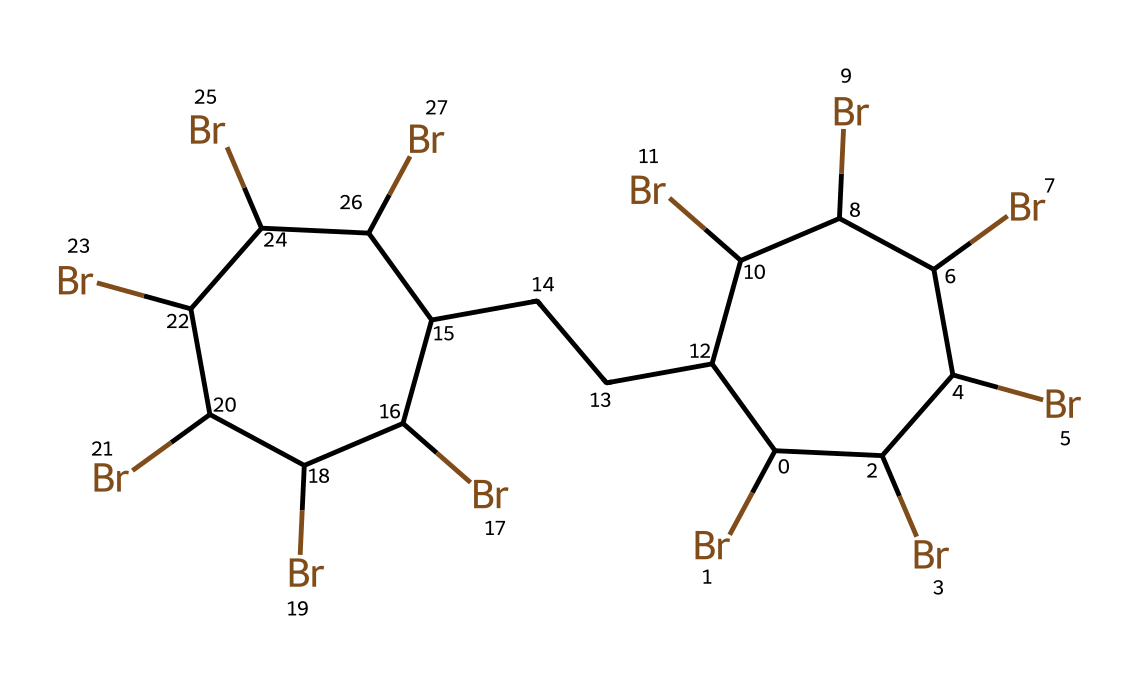What is the central element in this compound? The presence of bromine atoms in the structure indicates that bromine is the central element, especially since it appears multiple times in the SMILES representation.
Answer: bromine How many bromine atoms are present in the structure? By counting the occurrences of 'Br' in the SMILES notation, there are a total of six bromine atoms represented in the chemical structure.
Answer: six What type of functional group does this structure exhibit? The structure displays multiple bromine attachments, representing a polybrominated flame retardant, which is characterized by having several bromine substituents.
Answer: polybrominated Is this chemical likely to be hydrophobic or hydrophilic? Given the presence of numerous bromine atoms and the overall structure of a polybrominated biphenyl, it suggests that the chemical is largely hydrophobic due to the bromination and lack of polar functional groups.
Answer: hydrophobic Why might this chemical be used in sports equipment? The presence of bromine indicates its use as a flame retardant, which is crucial in sports equipment to enhance safety against fire hazards.
Answer: flame retardant What property of bromine is primarily utilized in this compound? The chemical structure utilizes bromine's ability to inhibit flame propagation, a property that makes it an effective flame retardant.
Answer: inhibit flame propagation 